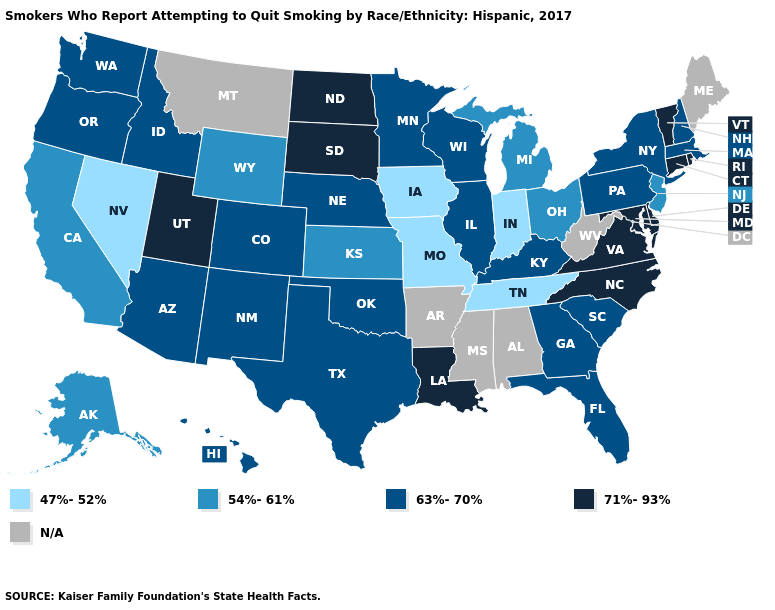Which states have the lowest value in the South?
Quick response, please. Tennessee. What is the value of California?
Concise answer only. 54%-61%. What is the lowest value in the USA?
Give a very brief answer. 47%-52%. What is the highest value in states that border Illinois?
Write a very short answer. 63%-70%. Which states have the lowest value in the Northeast?
Give a very brief answer. New Jersey. Which states have the highest value in the USA?
Give a very brief answer. Connecticut, Delaware, Louisiana, Maryland, North Carolina, North Dakota, Rhode Island, South Dakota, Utah, Vermont, Virginia. How many symbols are there in the legend?
Write a very short answer. 5. What is the value of Idaho?
Be succinct. 63%-70%. Which states have the highest value in the USA?
Give a very brief answer. Connecticut, Delaware, Louisiana, Maryland, North Carolina, North Dakota, Rhode Island, South Dakota, Utah, Vermont, Virginia. What is the value of Mississippi?
Quick response, please. N/A. What is the value of Hawaii?
Be succinct. 63%-70%. What is the lowest value in the USA?
Short answer required. 47%-52%. Does the map have missing data?
Write a very short answer. Yes. How many symbols are there in the legend?
Answer briefly. 5. What is the highest value in states that border Tennessee?
Be succinct. 71%-93%. 